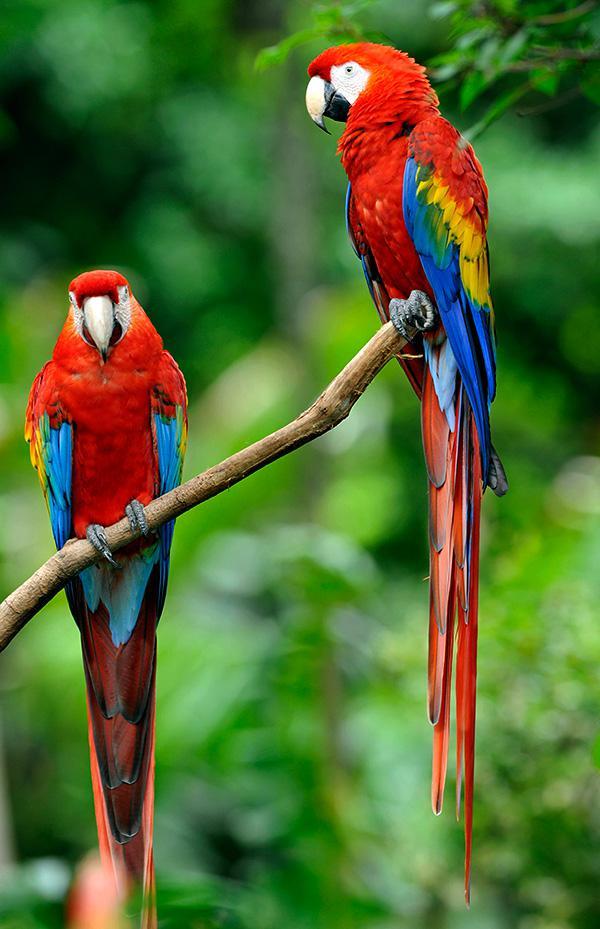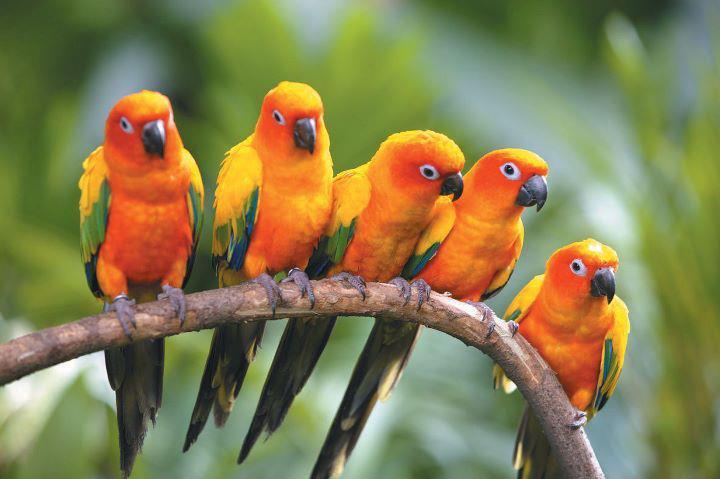The first image is the image on the left, the second image is the image on the right. Given the left and right images, does the statement "One of the images contains exactly five birds." hold true? Answer yes or no. Yes. 